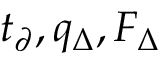<formula> <loc_0><loc_0><loc_500><loc_500>t _ { \partial } , q _ { \Delta } , F _ { \Delta }</formula> 